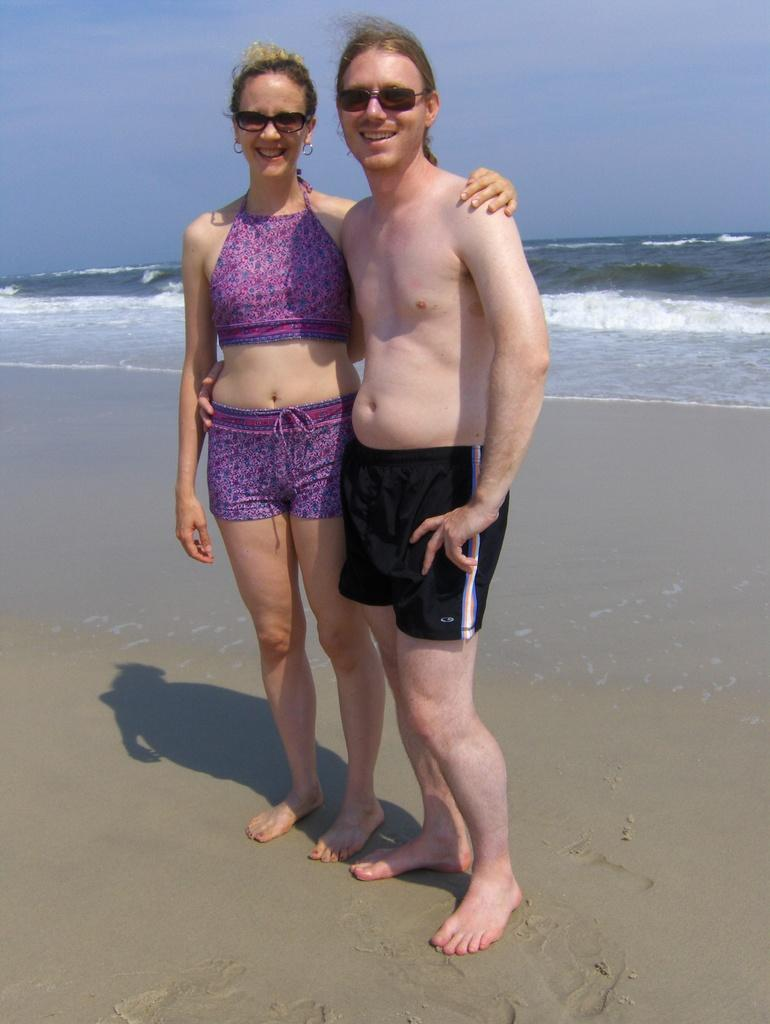How many people are in the image? There are two people in the image. Where are the people located in the image? The people are standing on a sea shore. What can be seen in the background of the image? There is an ocean and sky visible in the background of the image. What type of terrain is at the bottom of the image? There is sand at the bottom of the image. What type of party is happening on the sand in the image? There is no party happening in the image; it simply shows two people standing on a sea shore. 